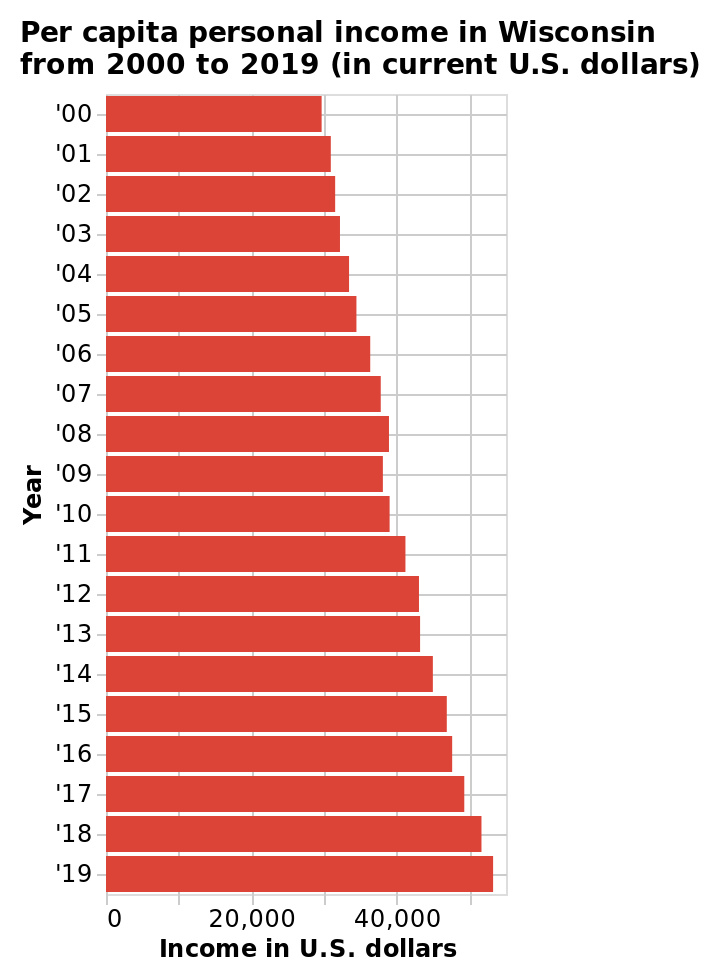<image>
Did per capita personal income in Wisconsin increase or decrease during the mentioned period?  Per capita personal income in Wisconsin increased during the mentioned period. What is the highest income value represented on the x-axis of the bar graph? The highest income value represented on the x-axis of the bar graph is $50,000. Offer a thorough analysis of the image. Per capita personal income in Wisconsin shows steady year on year growth between 2000 and 2019. What is the range of income values represented on the x-axis of the bar graph?  The range of income values represented on the x-axis of the bar graph is from $0 to $50,000. What were the years included in the period of steady year on year growth of per capita personal income in Wisconsin? The period of steady year on year growth of per capita personal income in Wisconsin includes the years from 2000 to 2019. Does the period of inconsistent year on year growth of per capita personal income in Wisconsin include the years from 2000 to 2019? No.The period of steady year on year growth of per capita personal income in Wisconsin includes the years from 2000 to 2019. 